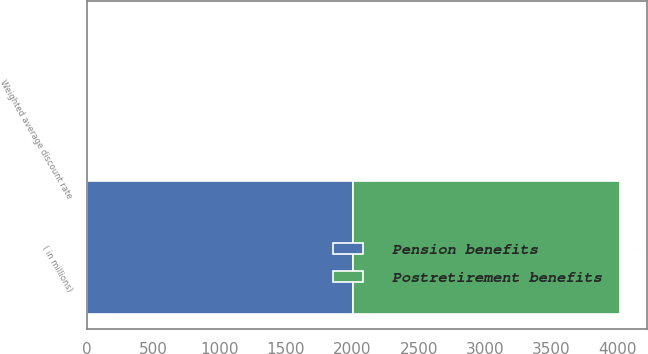Convert chart to OTSL. <chart><loc_0><loc_0><loc_500><loc_500><stacked_bar_chart><ecel><fcel>( in millions)<fcel>Weighted average discount rate<nl><fcel>Postretirement benefits<fcel>2008<fcel>6.5<nl><fcel>Pension benefits<fcel>2008<fcel>6.75<nl></chart> 